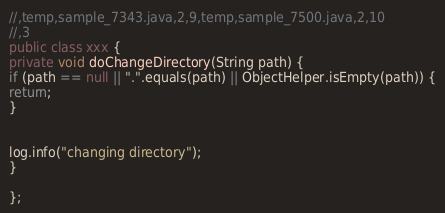<code> <loc_0><loc_0><loc_500><loc_500><_Java_>//,temp,sample_7343.java,2,9,temp,sample_7500.java,2,10
//,3
public class xxx {
private void doChangeDirectory(String path) {
if (path == null || ".".equals(path) || ObjectHelper.isEmpty(path)) {
return;
}


log.info("changing directory");
}

};</code> 